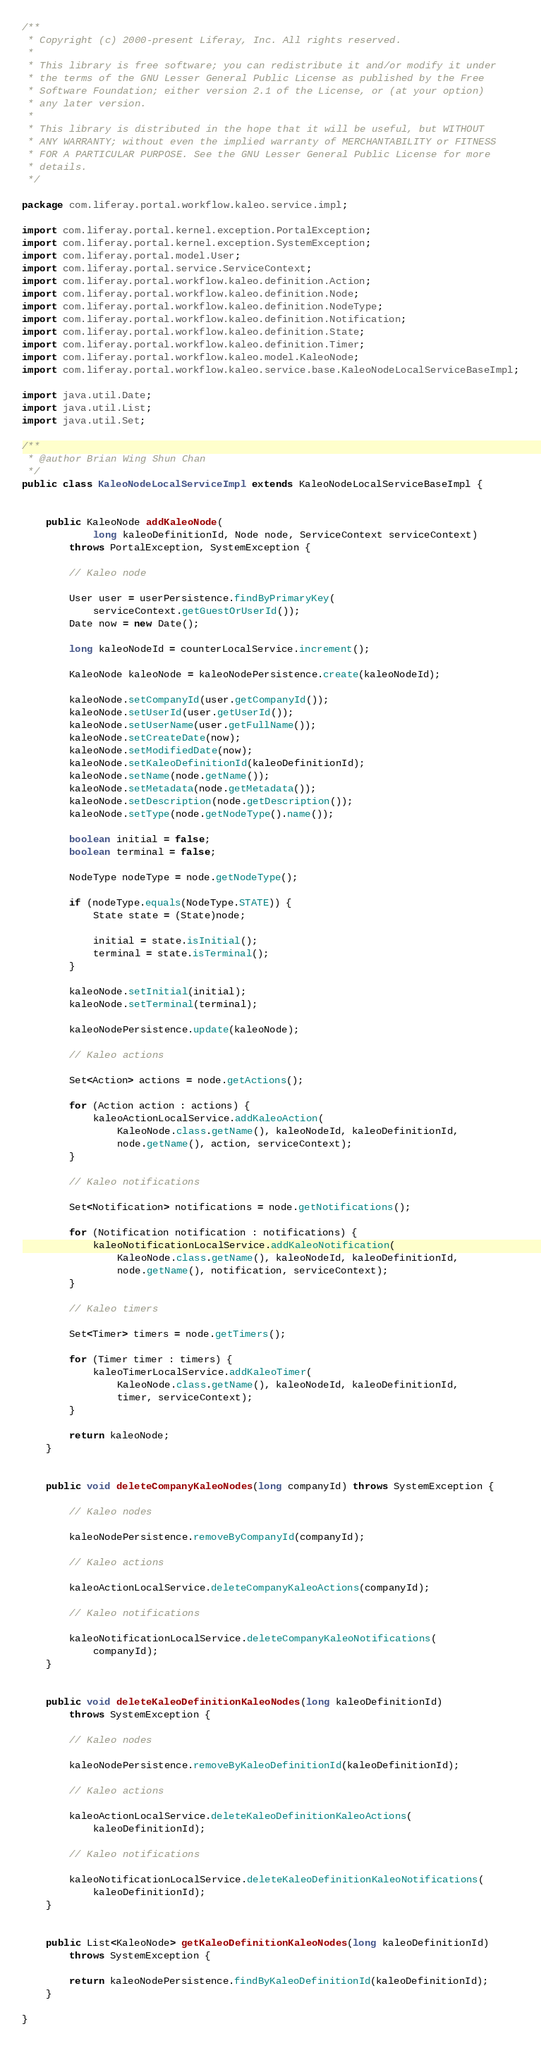<code> <loc_0><loc_0><loc_500><loc_500><_Java_>/**
 * Copyright (c) 2000-present Liferay, Inc. All rights reserved.
 *
 * This library is free software; you can redistribute it and/or modify it under
 * the terms of the GNU Lesser General Public License as published by the Free
 * Software Foundation; either version 2.1 of the License, or (at your option)
 * any later version.
 *
 * This library is distributed in the hope that it will be useful, but WITHOUT
 * ANY WARRANTY; without even the implied warranty of MERCHANTABILITY or FITNESS
 * FOR A PARTICULAR PURPOSE. See the GNU Lesser General Public License for more
 * details.
 */

package com.liferay.portal.workflow.kaleo.service.impl;

import com.liferay.portal.kernel.exception.PortalException;
import com.liferay.portal.kernel.exception.SystemException;
import com.liferay.portal.model.User;
import com.liferay.portal.service.ServiceContext;
import com.liferay.portal.workflow.kaleo.definition.Action;
import com.liferay.portal.workflow.kaleo.definition.Node;
import com.liferay.portal.workflow.kaleo.definition.NodeType;
import com.liferay.portal.workflow.kaleo.definition.Notification;
import com.liferay.portal.workflow.kaleo.definition.State;
import com.liferay.portal.workflow.kaleo.definition.Timer;
import com.liferay.portal.workflow.kaleo.model.KaleoNode;
import com.liferay.portal.workflow.kaleo.service.base.KaleoNodeLocalServiceBaseImpl;

import java.util.Date;
import java.util.List;
import java.util.Set;

/**
 * @author Brian Wing Shun Chan
 */
public class KaleoNodeLocalServiceImpl extends KaleoNodeLocalServiceBaseImpl {


	public KaleoNode addKaleoNode(
			long kaleoDefinitionId, Node node, ServiceContext serviceContext)
		throws PortalException, SystemException {

		// Kaleo node

		User user = userPersistence.findByPrimaryKey(
			serviceContext.getGuestOrUserId());
		Date now = new Date();

		long kaleoNodeId = counterLocalService.increment();

		KaleoNode kaleoNode = kaleoNodePersistence.create(kaleoNodeId);

		kaleoNode.setCompanyId(user.getCompanyId());
		kaleoNode.setUserId(user.getUserId());
		kaleoNode.setUserName(user.getFullName());
		kaleoNode.setCreateDate(now);
		kaleoNode.setModifiedDate(now);
		kaleoNode.setKaleoDefinitionId(kaleoDefinitionId);
		kaleoNode.setName(node.getName());
		kaleoNode.setMetadata(node.getMetadata());
		kaleoNode.setDescription(node.getDescription());
		kaleoNode.setType(node.getNodeType().name());

		boolean initial = false;
		boolean terminal = false;

		NodeType nodeType = node.getNodeType();

		if (nodeType.equals(NodeType.STATE)) {
			State state = (State)node;

			initial = state.isInitial();
			terminal = state.isTerminal();
		}

		kaleoNode.setInitial(initial);
		kaleoNode.setTerminal(terminal);

		kaleoNodePersistence.update(kaleoNode);

		// Kaleo actions

		Set<Action> actions = node.getActions();

		for (Action action : actions) {
			kaleoActionLocalService.addKaleoAction(
				KaleoNode.class.getName(), kaleoNodeId, kaleoDefinitionId,
				node.getName(), action, serviceContext);
		}

		// Kaleo notifications

		Set<Notification> notifications = node.getNotifications();

		for (Notification notification : notifications) {
			kaleoNotificationLocalService.addKaleoNotification(
				KaleoNode.class.getName(), kaleoNodeId, kaleoDefinitionId,
				node.getName(), notification, serviceContext);
		}

		// Kaleo timers

		Set<Timer> timers = node.getTimers();

		for (Timer timer : timers) {
			kaleoTimerLocalService.addKaleoTimer(
				KaleoNode.class.getName(), kaleoNodeId, kaleoDefinitionId,
				timer, serviceContext);
		}

		return kaleoNode;
	}


	public void deleteCompanyKaleoNodes(long companyId) throws SystemException {

		// Kaleo nodes

		kaleoNodePersistence.removeByCompanyId(companyId);

		// Kaleo actions

		kaleoActionLocalService.deleteCompanyKaleoActions(companyId);

		// Kaleo notifications

		kaleoNotificationLocalService.deleteCompanyKaleoNotifications(
			companyId);
	}


	public void deleteKaleoDefinitionKaleoNodes(long kaleoDefinitionId)
		throws SystemException {

		// Kaleo nodes

		kaleoNodePersistence.removeByKaleoDefinitionId(kaleoDefinitionId);

		// Kaleo actions

		kaleoActionLocalService.deleteKaleoDefinitionKaleoActions(
			kaleoDefinitionId);

		// Kaleo notifications

		kaleoNotificationLocalService.deleteKaleoDefinitionKaleoNotifications(
			kaleoDefinitionId);
	}


	public List<KaleoNode> getKaleoDefinitionKaleoNodes(long kaleoDefinitionId)
		throws SystemException {

		return kaleoNodePersistence.findByKaleoDefinitionId(kaleoDefinitionId);
	}

}</code> 